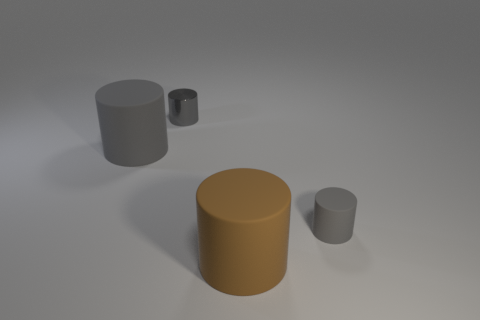Does the brown rubber thing have the same shape as the tiny metallic object?
Provide a short and direct response. Yes. Are there any other things that are the same shape as the gray shiny thing?
Keep it short and to the point. Yes. Do the thing that is on the left side of the gray metal object and the large thing to the right of the gray metallic thing have the same color?
Offer a terse response. No. Are there fewer gray matte cylinders that are left of the tiny gray rubber object than big gray cylinders that are to the right of the brown cylinder?
Offer a very short reply. No. What shape is the large thing to the right of the small gray metallic cylinder?
Make the answer very short. Cylinder. There is another tiny cylinder that is the same color as the small rubber cylinder; what material is it?
Your answer should be compact. Metal. What number of other things are the same material as the big brown cylinder?
Your answer should be compact. 2. There is a large gray thing; does it have the same shape as the tiny object behind the small rubber cylinder?
Offer a very short reply. Yes. What shape is the big thing that is made of the same material as the big brown cylinder?
Your answer should be very brief. Cylinder. Are there more cylinders that are in front of the small gray rubber object than big gray matte objects that are right of the big gray matte object?
Your answer should be very brief. Yes. 